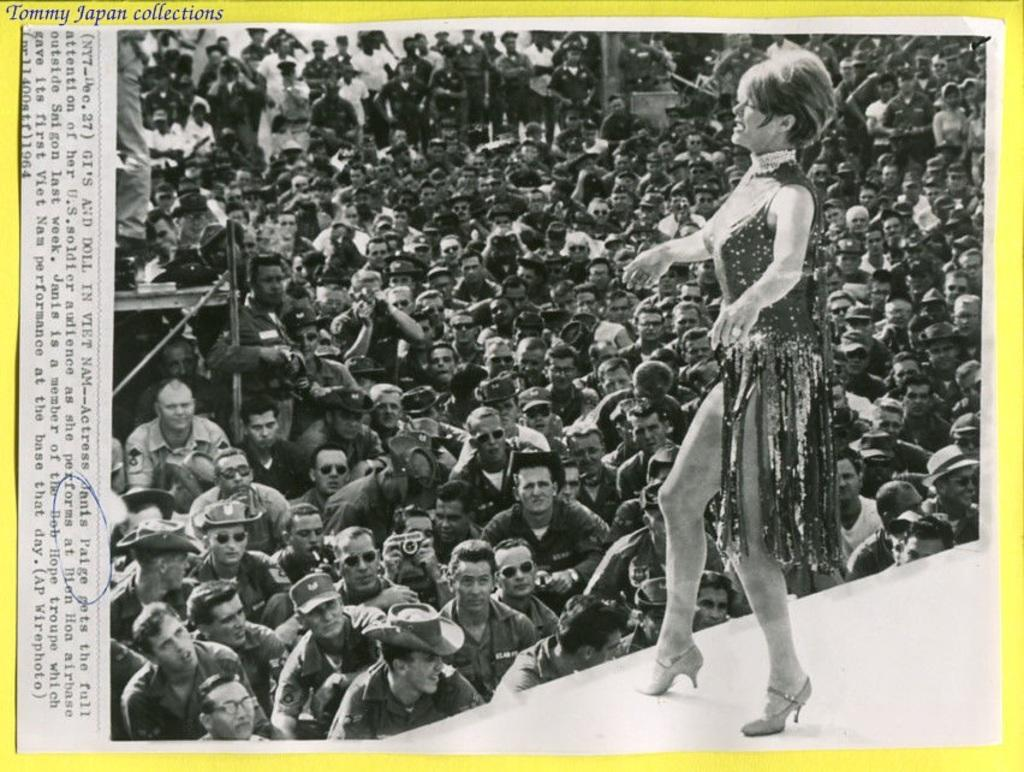What is the woman in the image doing? The woman is standing on a stage in the image. What are the people in the image doing? The people are standing and watching the woman on the stage. Can you describe any text visible in the image? Yes, there is some text visible in the image. What type of haircut does the woman on the stage have in the image? There is no information about the woman's haircut in the image. What news event is being discussed on the stage in the image? There is no news event being discussed on the stage in the image. 